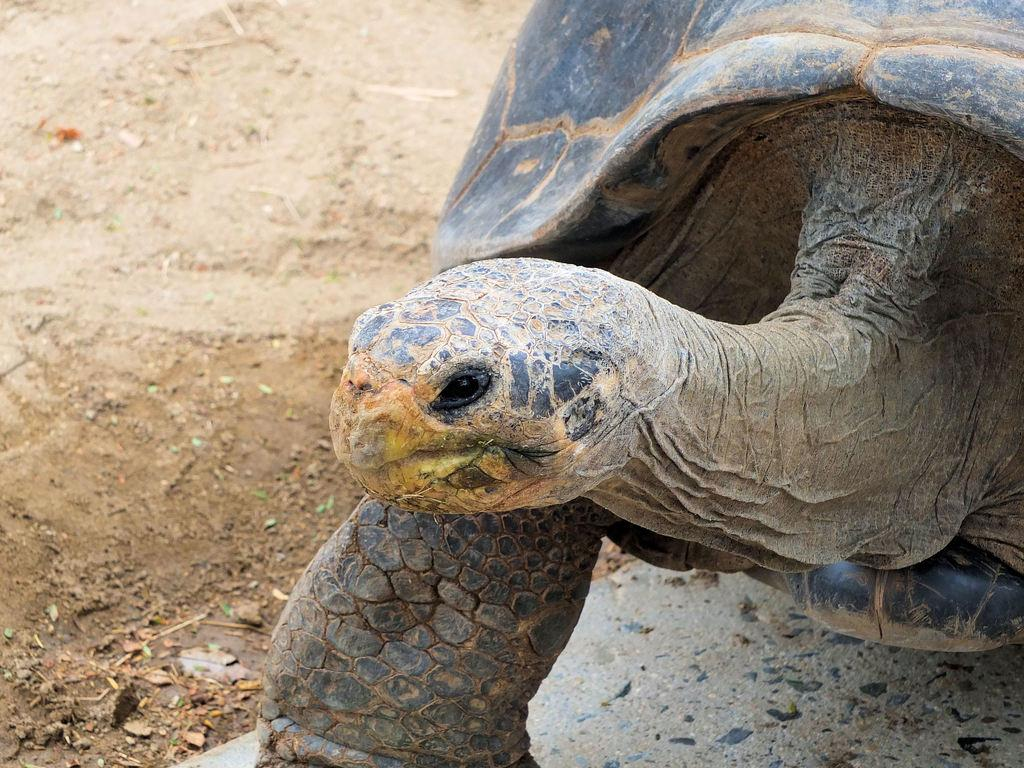What type of animal can be seen in the image? There is a turtle in the image. What is the background or surface visible in the image? The surface is visible in the image. How many wires are connected to the turtle's shell in the image? There are no wires connected to the turtle's shell in the image. Where is the nest of the turtle located in the image? There is no nest present in the image; it only features a turtle and a visible surface. 